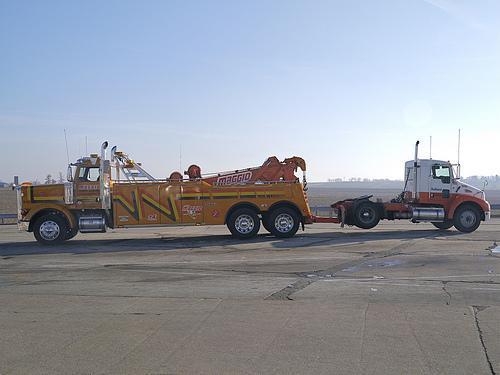How many trucks on the road?
Give a very brief answer. 1. 